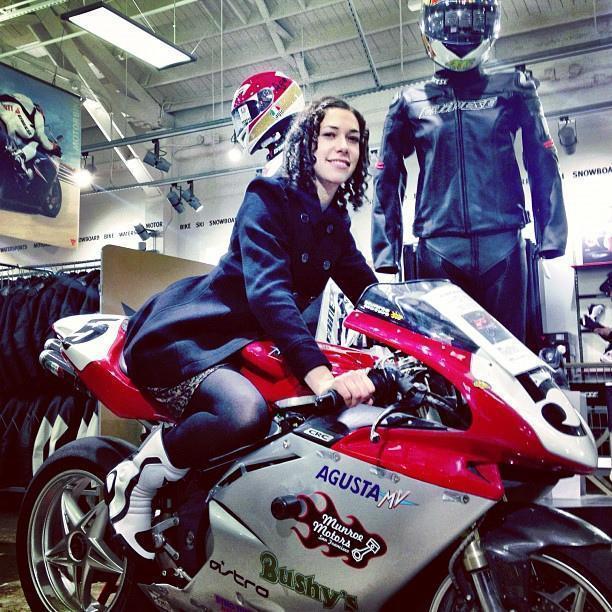What does the woman have on her feet?
From the following set of four choices, select the accurate answer to respond to the question.
Options: Seashells, sneakers, sandals, boots. Boots. 